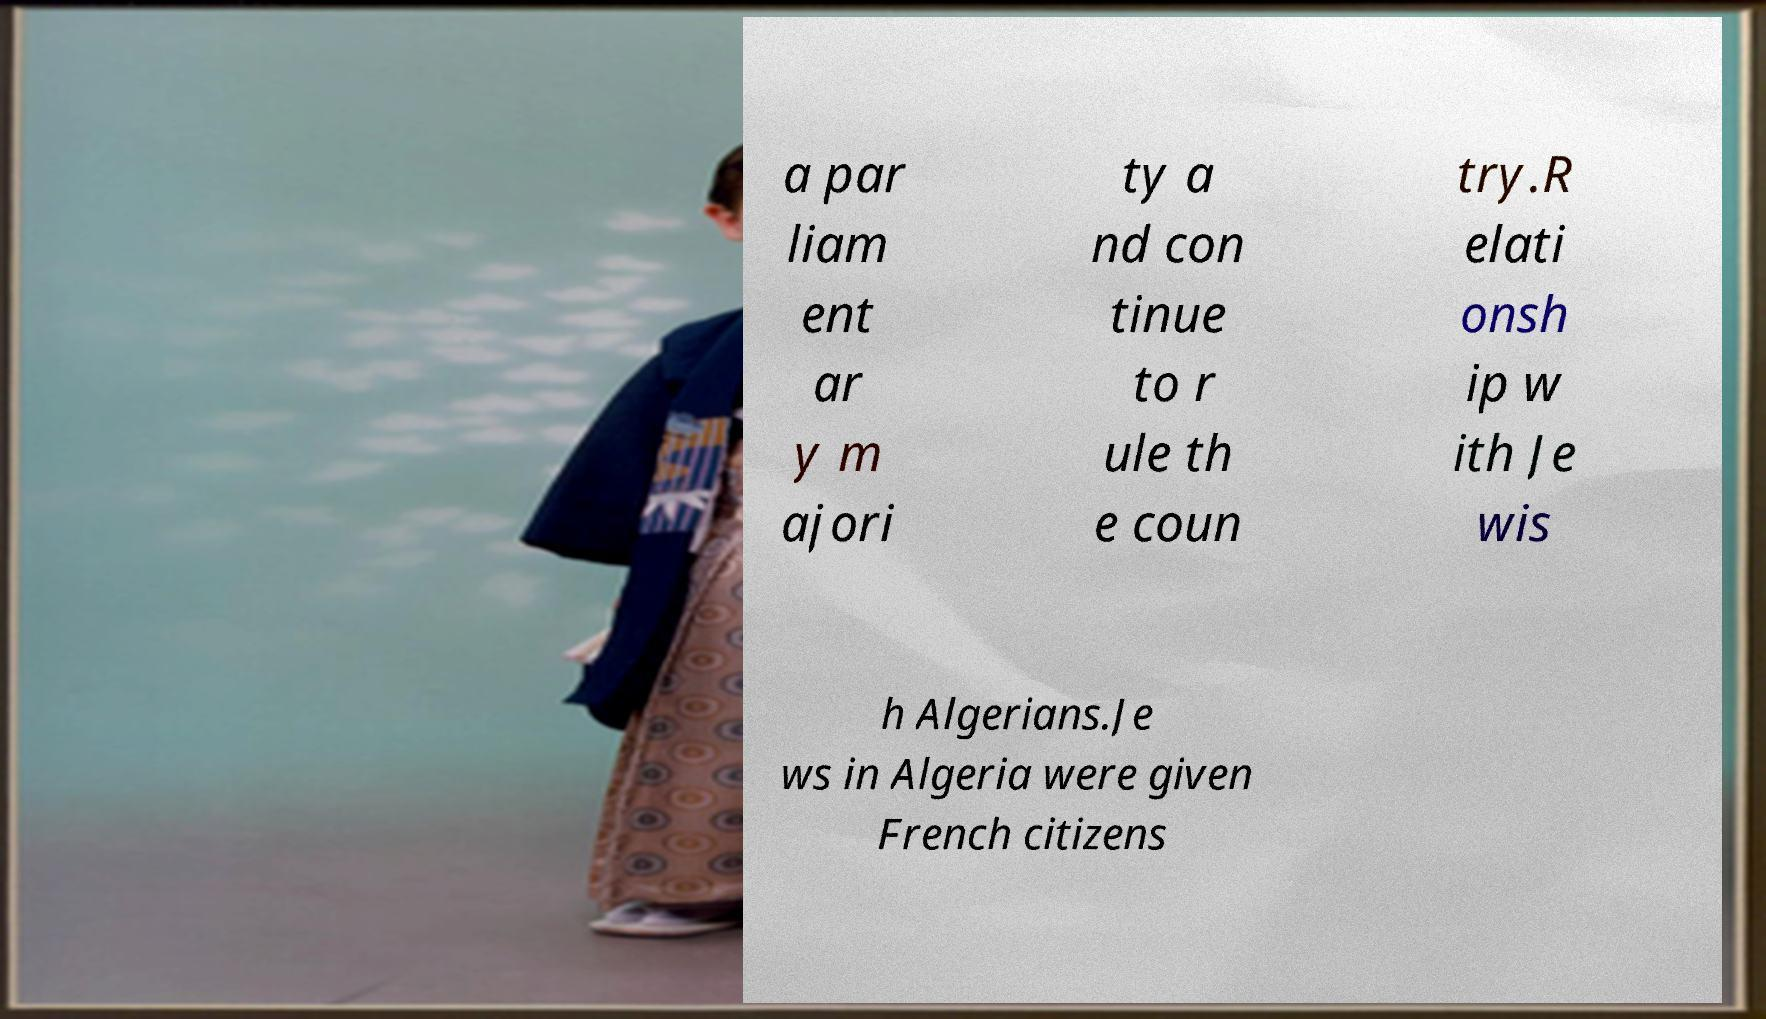There's text embedded in this image that I need extracted. Can you transcribe it verbatim? a par liam ent ar y m ajori ty a nd con tinue to r ule th e coun try.R elati onsh ip w ith Je wis h Algerians.Je ws in Algeria were given French citizens 